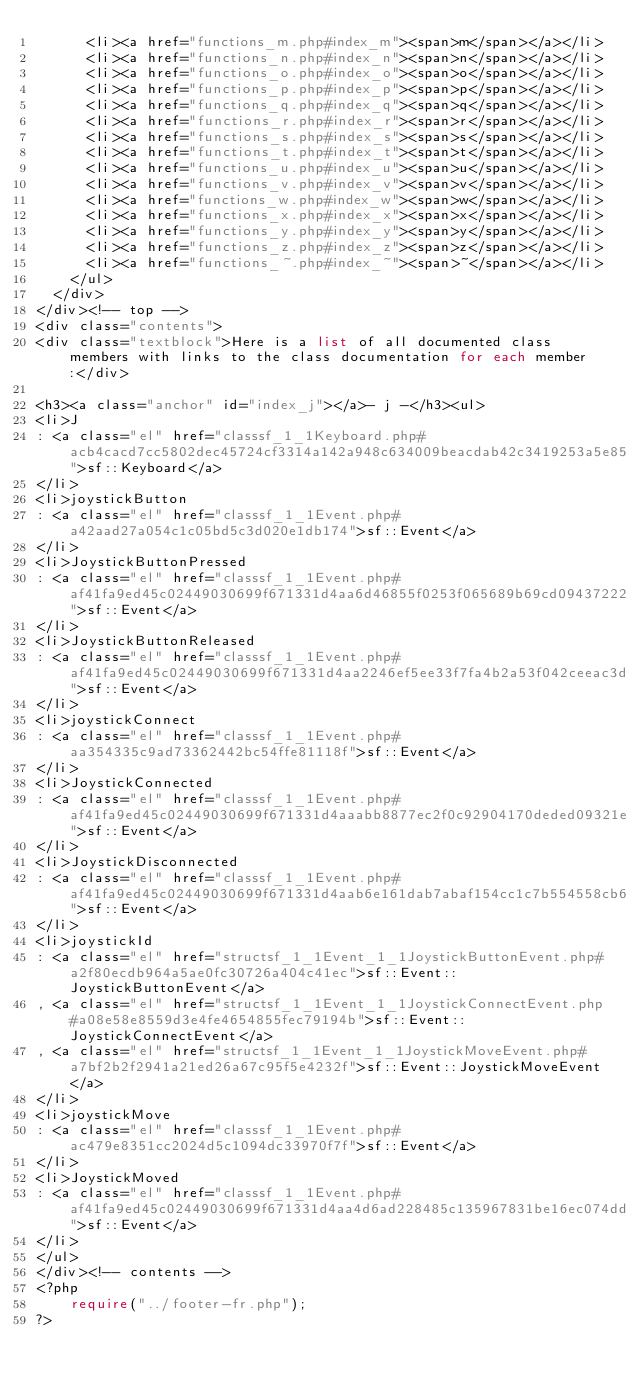<code> <loc_0><loc_0><loc_500><loc_500><_PHP_>      <li><a href="functions_m.php#index_m"><span>m</span></a></li>
      <li><a href="functions_n.php#index_n"><span>n</span></a></li>
      <li><a href="functions_o.php#index_o"><span>o</span></a></li>
      <li><a href="functions_p.php#index_p"><span>p</span></a></li>
      <li><a href="functions_q.php#index_q"><span>q</span></a></li>
      <li><a href="functions_r.php#index_r"><span>r</span></a></li>
      <li><a href="functions_s.php#index_s"><span>s</span></a></li>
      <li><a href="functions_t.php#index_t"><span>t</span></a></li>
      <li><a href="functions_u.php#index_u"><span>u</span></a></li>
      <li><a href="functions_v.php#index_v"><span>v</span></a></li>
      <li><a href="functions_w.php#index_w"><span>w</span></a></li>
      <li><a href="functions_x.php#index_x"><span>x</span></a></li>
      <li><a href="functions_y.php#index_y"><span>y</span></a></li>
      <li><a href="functions_z.php#index_z"><span>z</span></a></li>
      <li><a href="functions_~.php#index_~"><span>~</span></a></li>
    </ul>
  </div>
</div><!-- top -->
<div class="contents">
<div class="textblock">Here is a list of all documented class members with links to the class documentation for each member:</div>

<h3><a class="anchor" id="index_j"></a>- j -</h3><ul>
<li>J
: <a class="el" href="classsf_1_1Keyboard.php#acb4cacd7cc5802dec45724cf3314a142a948c634009beacdab42c3419253a5e85">sf::Keyboard</a>
</li>
<li>joystickButton
: <a class="el" href="classsf_1_1Event.php#a42aad27a054c1c05bd5c3d020e1db174">sf::Event</a>
</li>
<li>JoystickButtonPressed
: <a class="el" href="classsf_1_1Event.php#af41fa9ed45c02449030699f671331d4aa6d46855f0253f065689b69cd09437222">sf::Event</a>
</li>
<li>JoystickButtonReleased
: <a class="el" href="classsf_1_1Event.php#af41fa9ed45c02449030699f671331d4aa2246ef5ee33f7fa4b2a53f042ceeac3d">sf::Event</a>
</li>
<li>joystickConnect
: <a class="el" href="classsf_1_1Event.php#aa354335c9ad73362442bc54ffe81118f">sf::Event</a>
</li>
<li>JoystickConnected
: <a class="el" href="classsf_1_1Event.php#af41fa9ed45c02449030699f671331d4aaabb8877ec2f0c92904170deded09321e">sf::Event</a>
</li>
<li>JoystickDisconnected
: <a class="el" href="classsf_1_1Event.php#af41fa9ed45c02449030699f671331d4aab6e161dab7abaf154cc1c7b554558cb6">sf::Event</a>
</li>
<li>joystickId
: <a class="el" href="structsf_1_1Event_1_1JoystickButtonEvent.php#a2f80ecdb964a5ae0fc30726a404c41ec">sf::Event::JoystickButtonEvent</a>
, <a class="el" href="structsf_1_1Event_1_1JoystickConnectEvent.php#a08e58e8559d3e4fe4654855fec79194b">sf::Event::JoystickConnectEvent</a>
, <a class="el" href="structsf_1_1Event_1_1JoystickMoveEvent.php#a7bf2b2f2941a21ed26a67c95f5e4232f">sf::Event::JoystickMoveEvent</a>
</li>
<li>joystickMove
: <a class="el" href="classsf_1_1Event.php#ac479e8351cc2024d5c1094dc33970f7f">sf::Event</a>
</li>
<li>JoystickMoved
: <a class="el" href="classsf_1_1Event.php#af41fa9ed45c02449030699f671331d4aa4d6ad228485c135967831be16ec074dd">sf::Event</a>
</li>
</ul>
</div><!-- contents -->
<?php
    require("../footer-fr.php");
?>
</code> 